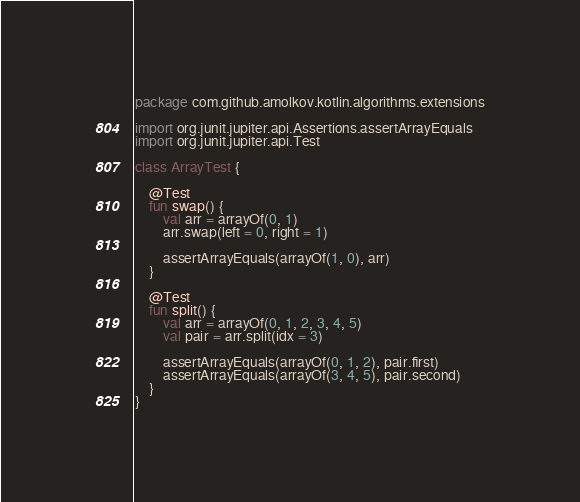Convert code to text. <code><loc_0><loc_0><loc_500><loc_500><_Kotlin_>package com.github.amolkov.kotlin.algorithms.extensions

import org.junit.jupiter.api.Assertions.assertArrayEquals
import org.junit.jupiter.api.Test

class ArrayTest {

    @Test
    fun swap() {
        val arr = arrayOf(0, 1)
        arr.swap(left = 0, right = 1)

        assertArrayEquals(arrayOf(1, 0), arr)
    }

    @Test
    fun split() {
        val arr = arrayOf(0, 1, 2, 3, 4, 5)
        val pair = arr.split(idx = 3)

        assertArrayEquals(arrayOf(0, 1, 2), pair.first)
        assertArrayEquals(arrayOf(3, 4, 5), pair.second)
    }
}
</code> 